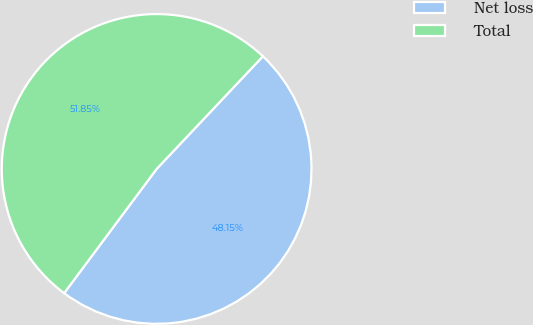Convert chart to OTSL. <chart><loc_0><loc_0><loc_500><loc_500><pie_chart><fcel>Net loss<fcel>Total<nl><fcel>48.15%<fcel>51.85%<nl></chart> 